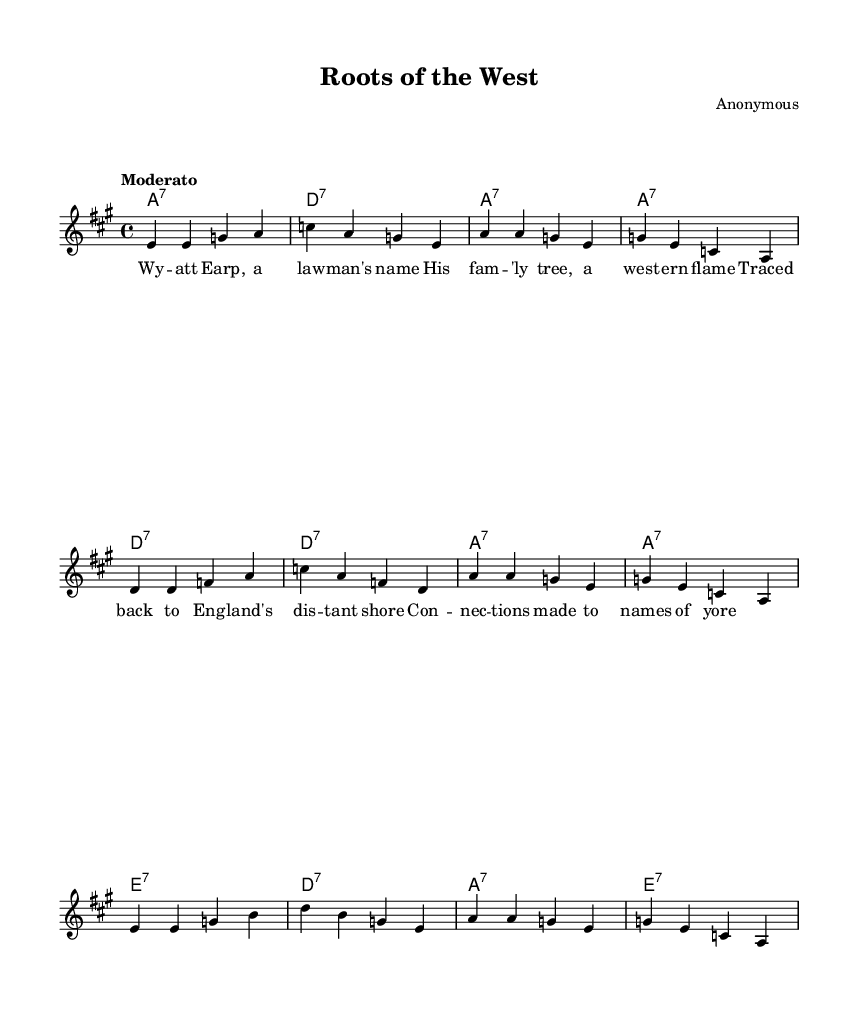What is the key signature of this music? The key signature is A major, which has three sharps: F#, C#, and G#. This is indicated at the beginning of the score.
Answer: A major What is the time signature of this music? The time signature is 4/4, which means there are four beats in each measure, and a quarter note gets one beat. This is shown at the beginning of the staff.
Answer: 4/4 What is the tempo marking of this music? The tempo marking is "Moderato," which indicates a moderate speed for the music. This appears at the beginning of the score under the global section.
Answer: Moderato How many measures are in the melody? The melody consists of 12 measures, as indicated by the grouping of notes and the underlying chord structure. You can count the measures based on the segments of the melody presented.
Answer: 12 What is the primary chord progression used in the harmonies? The primary chord progression is A7, D7, and E7, which are typical chords in blues music. This can be seen in the chord mode section throughout the score.
Answer: A7, D7, E7 What genre does this piece of music belong to? This piece is classified as Electric Blues, as indicated by the style and structure of the music, along with the specific guitar chords and lyrical themes evident in the score.
Answer: Electric Blues 